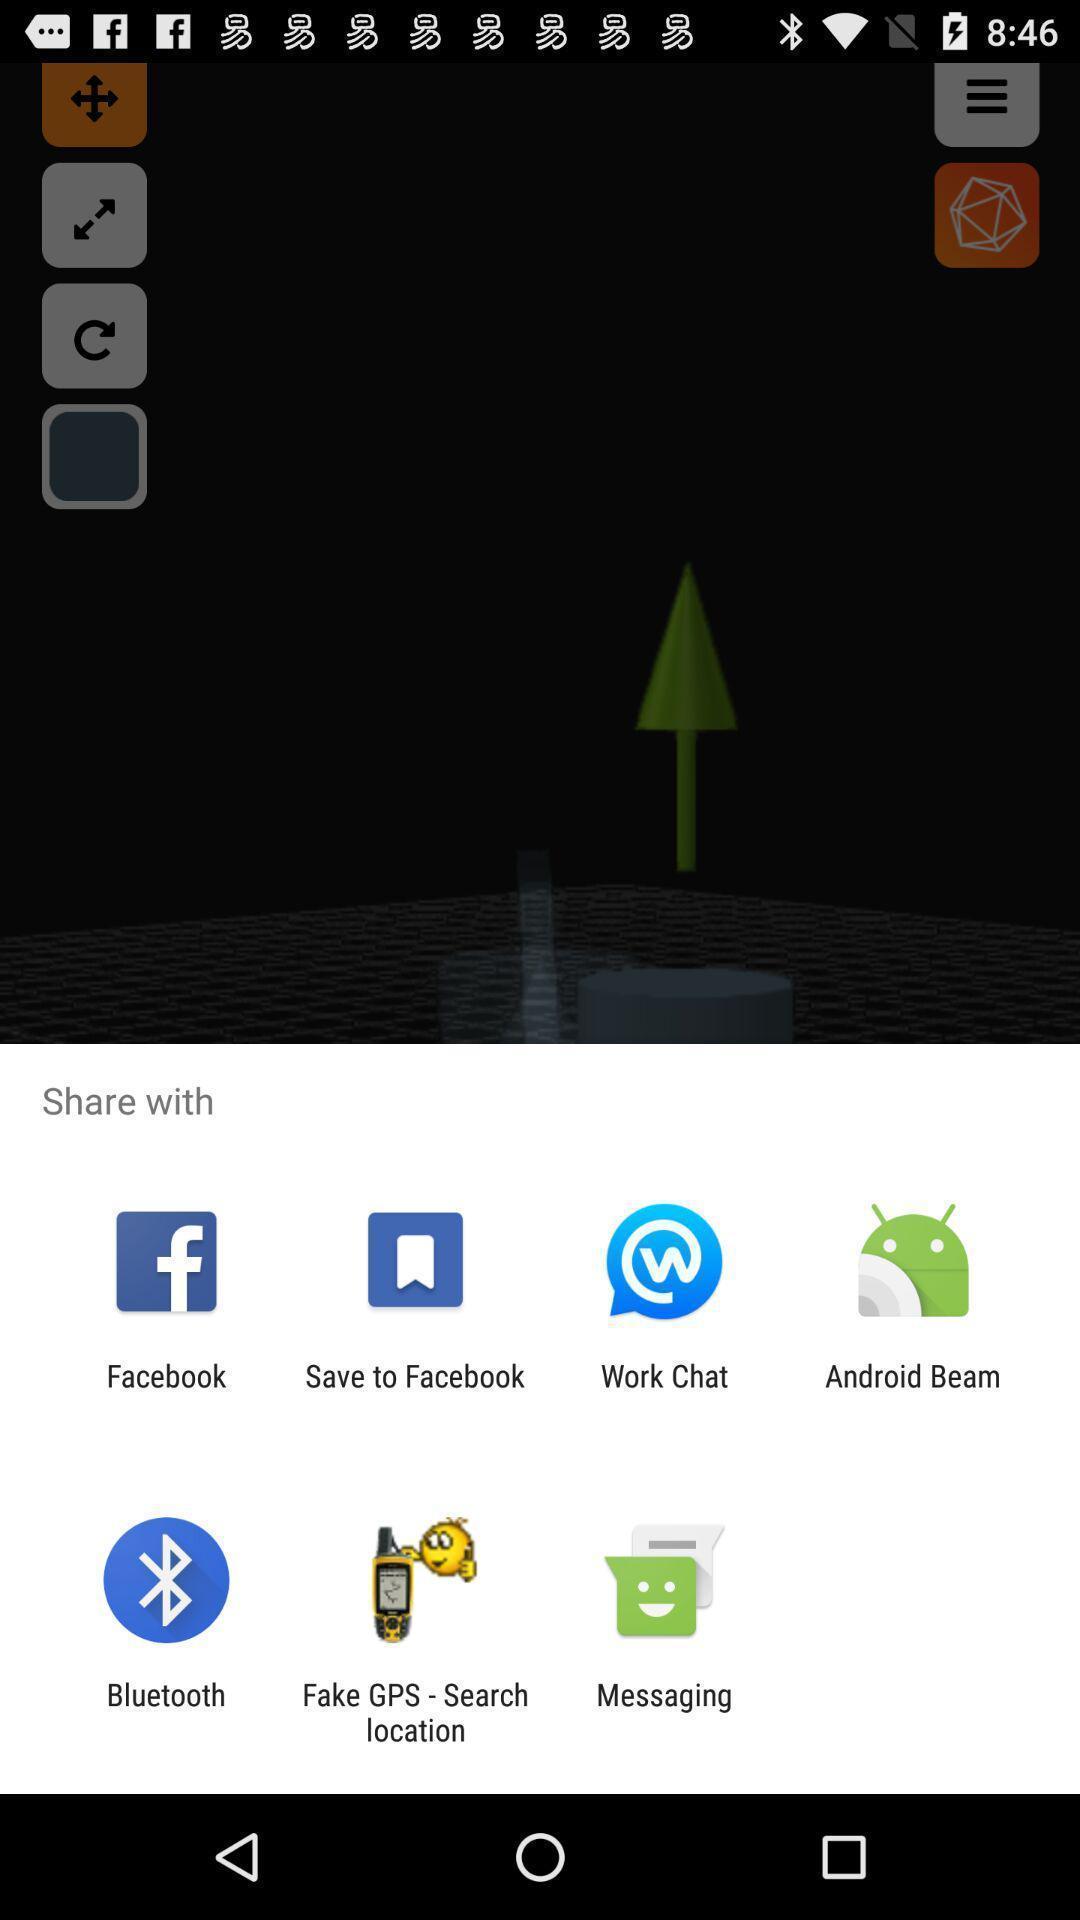Provide a description of this screenshot. Pop-up displaying various apps to share data. 